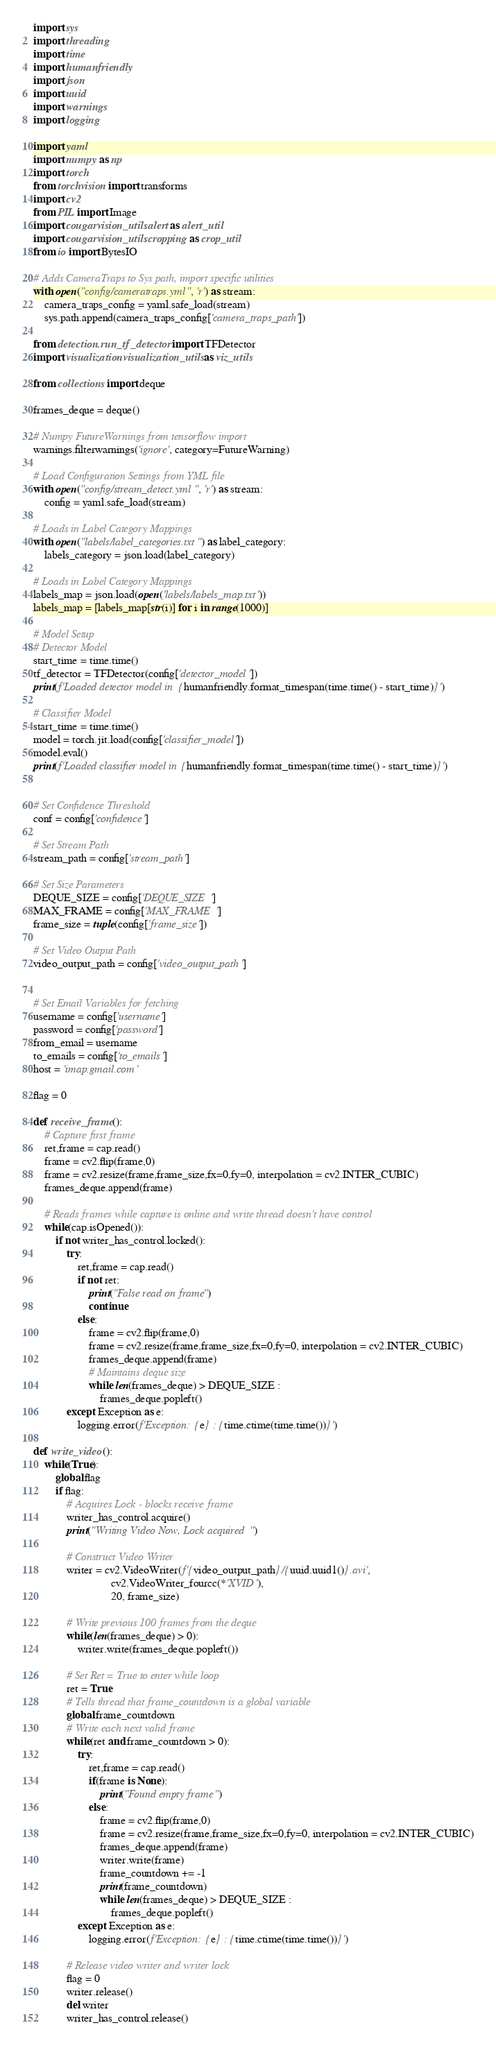<code> <loc_0><loc_0><loc_500><loc_500><_Python_>import sys
import threading
import time 
import humanfriendly
import json 
import uuid
import warnings
import logging

import yaml
import numpy as np
import torch 
from torchvision import transforms
import cv2 
from PIL import Image
import cougarvision_utils.alert as alert_util
import cougarvision_utils.cropping as crop_util
from io import BytesIO

# Adds CameraTraps to Sys path, import specific utilities
with open("config/cameratraps.yml", 'r') as stream:
    camera_traps_config = yaml.safe_load(stream)
    sys.path.append(camera_traps_config['camera_traps_path'])

from detection.run_tf_detector import TFDetector
import visualization.visualization_utils as viz_utils

from collections import deque

frames_deque = deque()

# Numpy FutureWarnings from tensorflow import
warnings.filterwarnings('ignore', category=FutureWarning)

# Load Configuration Settings from YML file
with open("config/stream_detect.yml", 'r') as stream:
    config = yaml.safe_load(stream)

# Loads in Label Category Mappings
with open("labels/label_categories.txt") as label_category:
    labels_category = json.load(label_category)

# Loads in Label Category Mappings
labels_map = json.load(open('labels/labels_map.txt'))
labels_map = [labels_map[str(i)] for i in range(1000)]

# Model Setup
# Detector Model
start_time = time.time()
tf_detector = TFDetector(config['detector_model'])
print(f'Loaded detector model in {humanfriendly.format_timespan(time.time() - start_time)}')

# Classifier Model
start_time = time.time()
model = torch.jit.load(config['classifier_model'])
model.eval()
print(f'Loaded classifier model in {humanfriendly.format_timespan(time.time() - start_time)}')

        
# Set Confidence Threshold
conf = config['confidence']

# Set Stream Path
stream_path = config['stream_path']

# Set Size Parameters
DEQUE_SIZE = config['DEQUE_SIZE']
MAX_FRAME = config['MAX_FRAME']
frame_size = tuple(config['frame_size'])

# Set Video Output Path
video_output_path = config['video_output_path']


# Set Email Variables for fetching
username = config['username']
password = config['password']
from_email = username
to_emails = config['to_emails']
host = 'imap.gmail.com'

flag = 0

def receive_frame():
    # Capture first frame
    ret,frame = cap.read()
    frame = cv2.flip(frame,0)
    frame = cv2.resize(frame,frame_size,fx=0,fy=0, interpolation = cv2.INTER_CUBIC)
    frames_deque.append(frame)

    # Reads frames while capture is online and write thread doesn't have control
    while(cap.isOpened()):
        if not writer_has_control.locked():
            try:
                ret,frame = cap.read()
                if not ret:
                    print("False read on frame")
                    continue
                else:
                    frame = cv2.flip(frame,0)
                    frame = cv2.resize(frame,frame_size,fx=0,fy=0, interpolation = cv2.INTER_CUBIC)
                    frames_deque.append(frame)
                    # Maintains deque size
                    while len(frames_deque) > DEQUE_SIZE :
                        frames_deque.popleft()
            except Exception as e:
                logging.error(f'Exception: {e} : {time.ctime(time.time())}')
      
def write_video():
    while(True):
        global flag
        if flag:
            # Acquires Lock - blocks receive frame
            writer_has_control.acquire()
            print("Writing Video Now, Lock acquired")
            
            # Construct Video Writer
            writer = cv2.VideoWriter(f'{video_output_path}/{uuid.uuid1()}.avi', 
                            cv2.VideoWriter_fourcc(*'XVID'),
                            20, frame_size)

            # Write previous 100 frames from the deque
            while(len(frames_deque) > 0):
                writer.write(frames_deque.popleft())

            # Set Ret = True to enter while loop
            ret = True
            # Tells thread that frame_countdown is a global variable
            global frame_countdown
            # Write each next valid frame 
            while(ret and frame_countdown > 0):
                try:
                    ret,frame = cap.read()
                    if(frame is None):
                        print("Found empty frame")
                    else:
                        frame = cv2.flip(frame,0)
                        frame = cv2.resize(frame,frame_size,fx=0,fy=0, interpolation = cv2.INTER_CUBIC)
                        frames_deque.append(frame)
                        writer.write(frame)
                        frame_countdown += -1
                        print(frame_countdown)
                        while len(frames_deque) > DEQUE_SIZE :
                            frames_deque.popleft()
                except Exception as e:
                    logging.error(f'Exception: {e} : {time.ctime(time.time())}')

            # Release video writer and writer lock
            flag = 0
            writer.release()
            del writer
            writer_has_control.release()
</code> 